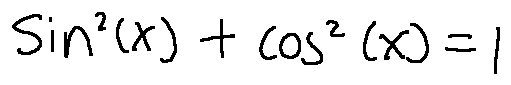<formula> <loc_0><loc_0><loc_500><loc_500>\sin ^ { 2 } ( x ) + \cos ^ { 2 } ( x ) = 1</formula> 